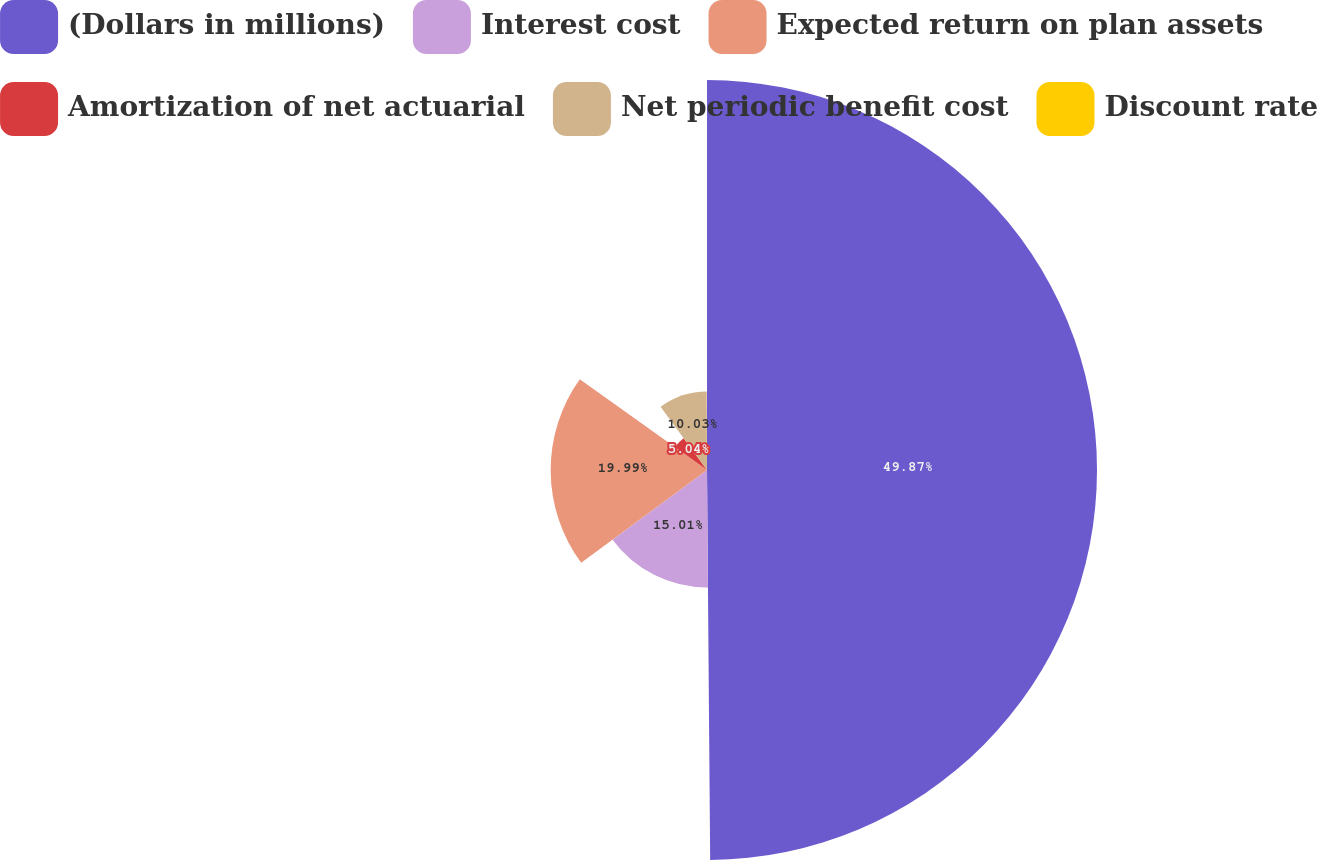Convert chart to OTSL. <chart><loc_0><loc_0><loc_500><loc_500><pie_chart><fcel>(Dollars in millions)<fcel>Interest cost<fcel>Expected return on plan assets<fcel>Amortization of net actuarial<fcel>Net periodic benefit cost<fcel>Discount rate<nl><fcel>49.87%<fcel>15.01%<fcel>19.99%<fcel>5.04%<fcel>10.03%<fcel>0.06%<nl></chart> 